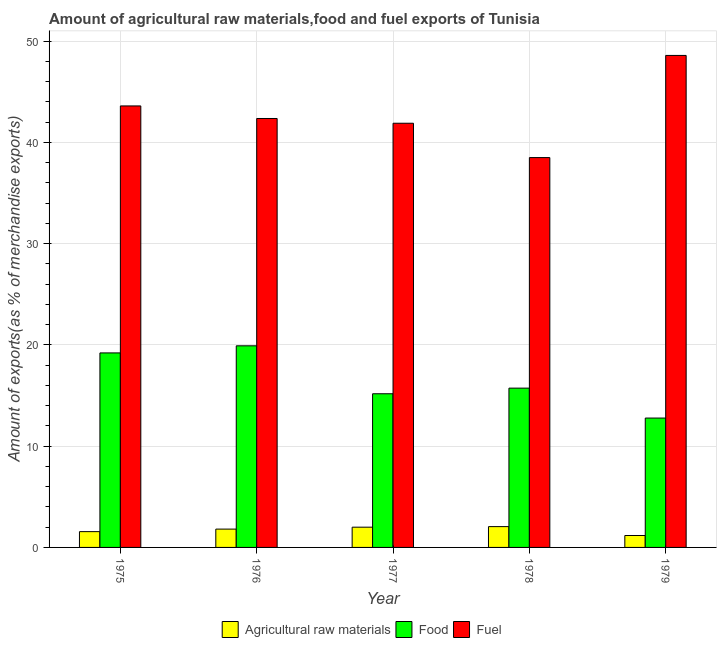How many groups of bars are there?
Ensure brevity in your answer.  5. How many bars are there on the 3rd tick from the left?
Ensure brevity in your answer.  3. How many bars are there on the 4th tick from the right?
Provide a short and direct response. 3. What is the label of the 4th group of bars from the left?
Your response must be concise. 1978. What is the percentage of food exports in 1976?
Ensure brevity in your answer.  19.91. Across all years, what is the maximum percentage of food exports?
Keep it short and to the point. 19.91. Across all years, what is the minimum percentage of raw materials exports?
Offer a terse response. 1.18. In which year was the percentage of food exports maximum?
Provide a succinct answer. 1976. In which year was the percentage of raw materials exports minimum?
Your answer should be very brief. 1979. What is the total percentage of raw materials exports in the graph?
Provide a succinct answer. 8.6. What is the difference between the percentage of food exports in 1975 and that in 1978?
Give a very brief answer. 3.48. What is the difference between the percentage of fuel exports in 1975 and the percentage of food exports in 1979?
Provide a succinct answer. -4.99. What is the average percentage of food exports per year?
Your answer should be very brief. 16.56. In the year 1975, what is the difference between the percentage of fuel exports and percentage of food exports?
Make the answer very short. 0. What is the ratio of the percentage of raw materials exports in 1975 to that in 1977?
Keep it short and to the point. 0.78. Is the percentage of food exports in 1978 less than that in 1979?
Ensure brevity in your answer.  No. Is the difference between the percentage of fuel exports in 1975 and 1978 greater than the difference between the percentage of raw materials exports in 1975 and 1978?
Provide a succinct answer. No. What is the difference between the highest and the second highest percentage of raw materials exports?
Offer a very short reply. 0.06. What is the difference between the highest and the lowest percentage of raw materials exports?
Make the answer very short. 0.88. Is the sum of the percentage of fuel exports in 1975 and 1979 greater than the maximum percentage of raw materials exports across all years?
Your answer should be very brief. Yes. What does the 2nd bar from the left in 1976 represents?
Ensure brevity in your answer.  Food. What does the 3rd bar from the right in 1976 represents?
Ensure brevity in your answer.  Agricultural raw materials. How many bars are there?
Make the answer very short. 15. Are all the bars in the graph horizontal?
Your answer should be very brief. No. How many years are there in the graph?
Your response must be concise. 5. What is the difference between two consecutive major ticks on the Y-axis?
Your answer should be very brief. 10. Are the values on the major ticks of Y-axis written in scientific E-notation?
Your response must be concise. No. How are the legend labels stacked?
Ensure brevity in your answer.  Horizontal. What is the title of the graph?
Offer a very short reply. Amount of agricultural raw materials,food and fuel exports of Tunisia. Does "Secondary education" appear as one of the legend labels in the graph?
Ensure brevity in your answer.  No. What is the label or title of the Y-axis?
Give a very brief answer. Amount of exports(as % of merchandise exports). What is the Amount of exports(as % of merchandise exports) in Agricultural raw materials in 1975?
Ensure brevity in your answer.  1.56. What is the Amount of exports(as % of merchandise exports) of Food in 1975?
Offer a very short reply. 19.21. What is the Amount of exports(as % of merchandise exports) of Fuel in 1975?
Give a very brief answer. 43.6. What is the Amount of exports(as % of merchandise exports) in Agricultural raw materials in 1976?
Make the answer very short. 1.81. What is the Amount of exports(as % of merchandise exports) of Food in 1976?
Keep it short and to the point. 19.91. What is the Amount of exports(as % of merchandise exports) of Fuel in 1976?
Your answer should be compact. 42.36. What is the Amount of exports(as % of merchandise exports) in Agricultural raw materials in 1977?
Provide a succinct answer. 2. What is the Amount of exports(as % of merchandise exports) in Food in 1977?
Provide a short and direct response. 15.17. What is the Amount of exports(as % of merchandise exports) of Fuel in 1977?
Keep it short and to the point. 41.89. What is the Amount of exports(as % of merchandise exports) of Agricultural raw materials in 1978?
Ensure brevity in your answer.  2.06. What is the Amount of exports(as % of merchandise exports) in Food in 1978?
Offer a terse response. 15.73. What is the Amount of exports(as % of merchandise exports) in Fuel in 1978?
Your answer should be very brief. 38.49. What is the Amount of exports(as % of merchandise exports) in Agricultural raw materials in 1979?
Offer a terse response. 1.18. What is the Amount of exports(as % of merchandise exports) of Food in 1979?
Offer a terse response. 12.77. What is the Amount of exports(as % of merchandise exports) of Fuel in 1979?
Your answer should be very brief. 48.58. Across all years, what is the maximum Amount of exports(as % of merchandise exports) in Agricultural raw materials?
Your response must be concise. 2.06. Across all years, what is the maximum Amount of exports(as % of merchandise exports) in Food?
Make the answer very short. 19.91. Across all years, what is the maximum Amount of exports(as % of merchandise exports) in Fuel?
Your answer should be very brief. 48.58. Across all years, what is the minimum Amount of exports(as % of merchandise exports) of Agricultural raw materials?
Give a very brief answer. 1.18. Across all years, what is the minimum Amount of exports(as % of merchandise exports) of Food?
Provide a succinct answer. 12.77. Across all years, what is the minimum Amount of exports(as % of merchandise exports) in Fuel?
Offer a very short reply. 38.49. What is the total Amount of exports(as % of merchandise exports) in Agricultural raw materials in the graph?
Offer a very short reply. 8.6. What is the total Amount of exports(as % of merchandise exports) in Food in the graph?
Give a very brief answer. 82.79. What is the total Amount of exports(as % of merchandise exports) in Fuel in the graph?
Offer a very short reply. 214.91. What is the difference between the Amount of exports(as % of merchandise exports) in Agricultural raw materials in 1975 and that in 1976?
Make the answer very short. -0.25. What is the difference between the Amount of exports(as % of merchandise exports) in Food in 1975 and that in 1976?
Keep it short and to the point. -0.7. What is the difference between the Amount of exports(as % of merchandise exports) in Fuel in 1975 and that in 1976?
Give a very brief answer. 1.24. What is the difference between the Amount of exports(as % of merchandise exports) in Agricultural raw materials in 1975 and that in 1977?
Provide a succinct answer. -0.44. What is the difference between the Amount of exports(as % of merchandise exports) in Food in 1975 and that in 1977?
Your answer should be very brief. 4.03. What is the difference between the Amount of exports(as % of merchandise exports) in Fuel in 1975 and that in 1977?
Make the answer very short. 1.71. What is the difference between the Amount of exports(as % of merchandise exports) of Agricultural raw materials in 1975 and that in 1978?
Your answer should be very brief. -0.5. What is the difference between the Amount of exports(as % of merchandise exports) of Food in 1975 and that in 1978?
Offer a terse response. 3.48. What is the difference between the Amount of exports(as % of merchandise exports) of Fuel in 1975 and that in 1978?
Offer a very short reply. 5.1. What is the difference between the Amount of exports(as % of merchandise exports) of Agricultural raw materials in 1975 and that in 1979?
Make the answer very short. 0.38. What is the difference between the Amount of exports(as % of merchandise exports) of Food in 1975 and that in 1979?
Your response must be concise. 6.43. What is the difference between the Amount of exports(as % of merchandise exports) in Fuel in 1975 and that in 1979?
Provide a short and direct response. -4.99. What is the difference between the Amount of exports(as % of merchandise exports) in Agricultural raw materials in 1976 and that in 1977?
Give a very brief answer. -0.19. What is the difference between the Amount of exports(as % of merchandise exports) in Food in 1976 and that in 1977?
Keep it short and to the point. 4.73. What is the difference between the Amount of exports(as % of merchandise exports) in Fuel in 1976 and that in 1977?
Make the answer very short. 0.47. What is the difference between the Amount of exports(as % of merchandise exports) of Agricultural raw materials in 1976 and that in 1978?
Provide a succinct answer. -0.25. What is the difference between the Amount of exports(as % of merchandise exports) of Food in 1976 and that in 1978?
Give a very brief answer. 4.18. What is the difference between the Amount of exports(as % of merchandise exports) of Fuel in 1976 and that in 1978?
Provide a short and direct response. 3.86. What is the difference between the Amount of exports(as % of merchandise exports) of Agricultural raw materials in 1976 and that in 1979?
Offer a terse response. 0.63. What is the difference between the Amount of exports(as % of merchandise exports) in Food in 1976 and that in 1979?
Your answer should be compact. 7.13. What is the difference between the Amount of exports(as % of merchandise exports) in Fuel in 1976 and that in 1979?
Your answer should be compact. -6.23. What is the difference between the Amount of exports(as % of merchandise exports) in Agricultural raw materials in 1977 and that in 1978?
Provide a short and direct response. -0.06. What is the difference between the Amount of exports(as % of merchandise exports) in Food in 1977 and that in 1978?
Offer a very short reply. -0.56. What is the difference between the Amount of exports(as % of merchandise exports) of Fuel in 1977 and that in 1978?
Make the answer very short. 3.39. What is the difference between the Amount of exports(as % of merchandise exports) of Agricultural raw materials in 1977 and that in 1979?
Offer a very short reply. 0.82. What is the difference between the Amount of exports(as % of merchandise exports) of Food in 1977 and that in 1979?
Provide a succinct answer. 2.4. What is the difference between the Amount of exports(as % of merchandise exports) of Fuel in 1977 and that in 1979?
Your answer should be compact. -6.7. What is the difference between the Amount of exports(as % of merchandise exports) in Agricultural raw materials in 1978 and that in 1979?
Offer a very short reply. 0.88. What is the difference between the Amount of exports(as % of merchandise exports) in Food in 1978 and that in 1979?
Your answer should be compact. 2.96. What is the difference between the Amount of exports(as % of merchandise exports) in Fuel in 1978 and that in 1979?
Provide a short and direct response. -10.09. What is the difference between the Amount of exports(as % of merchandise exports) of Agricultural raw materials in 1975 and the Amount of exports(as % of merchandise exports) of Food in 1976?
Provide a short and direct response. -18.35. What is the difference between the Amount of exports(as % of merchandise exports) of Agricultural raw materials in 1975 and the Amount of exports(as % of merchandise exports) of Fuel in 1976?
Your answer should be compact. -40.8. What is the difference between the Amount of exports(as % of merchandise exports) in Food in 1975 and the Amount of exports(as % of merchandise exports) in Fuel in 1976?
Make the answer very short. -23.15. What is the difference between the Amount of exports(as % of merchandise exports) in Agricultural raw materials in 1975 and the Amount of exports(as % of merchandise exports) in Food in 1977?
Your answer should be compact. -13.61. What is the difference between the Amount of exports(as % of merchandise exports) of Agricultural raw materials in 1975 and the Amount of exports(as % of merchandise exports) of Fuel in 1977?
Keep it short and to the point. -40.33. What is the difference between the Amount of exports(as % of merchandise exports) in Food in 1975 and the Amount of exports(as % of merchandise exports) in Fuel in 1977?
Provide a short and direct response. -22.68. What is the difference between the Amount of exports(as % of merchandise exports) in Agricultural raw materials in 1975 and the Amount of exports(as % of merchandise exports) in Food in 1978?
Ensure brevity in your answer.  -14.17. What is the difference between the Amount of exports(as % of merchandise exports) of Agricultural raw materials in 1975 and the Amount of exports(as % of merchandise exports) of Fuel in 1978?
Offer a terse response. -36.94. What is the difference between the Amount of exports(as % of merchandise exports) in Food in 1975 and the Amount of exports(as % of merchandise exports) in Fuel in 1978?
Your answer should be compact. -19.29. What is the difference between the Amount of exports(as % of merchandise exports) of Agricultural raw materials in 1975 and the Amount of exports(as % of merchandise exports) of Food in 1979?
Give a very brief answer. -11.21. What is the difference between the Amount of exports(as % of merchandise exports) of Agricultural raw materials in 1975 and the Amount of exports(as % of merchandise exports) of Fuel in 1979?
Your response must be concise. -47.02. What is the difference between the Amount of exports(as % of merchandise exports) of Food in 1975 and the Amount of exports(as % of merchandise exports) of Fuel in 1979?
Ensure brevity in your answer.  -29.38. What is the difference between the Amount of exports(as % of merchandise exports) of Agricultural raw materials in 1976 and the Amount of exports(as % of merchandise exports) of Food in 1977?
Provide a short and direct response. -13.37. What is the difference between the Amount of exports(as % of merchandise exports) of Agricultural raw materials in 1976 and the Amount of exports(as % of merchandise exports) of Fuel in 1977?
Provide a short and direct response. -40.08. What is the difference between the Amount of exports(as % of merchandise exports) of Food in 1976 and the Amount of exports(as % of merchandise exports) of Fuel in 1977?
Give a very brief answer. -21.98. What is the difference between the Amount of exports(as % of merchandise exports) of Agricultural raw materials in 1976 and the Amount of exports(as % of merchandise exports) of Food in 1978?
Provide a succinct answer. -13.92. What is the difference between the Amount of exports(as % of merchandise exports) of Agricultural raw materials in 1976 and the Amount of exports(as % of merchandise exports) of Fuel in 1978?
Provide a short and direct response. -36.69. What is the difference between the Amount of exports(as % of merchandise exports) in Food in 1976 and the Amount of exports(as % of merchandise exports) in Fuel in 1978?
Ensure brevity in your answer.  -18.59. What is the difference between the Amount of exports(as % of merchandise exports) of Agricultural raw materials in 1976 and the Amount of exports(as % of merchandise exports) of Food in 1979?
Keep it short and to the point. -10.97. What is the difference between the Amount of exports(as % of merchandise exports) in Agricultural raw materials in 1976 and the Amount of exports(as % of merchandise exports) in Fuel in 1979?
Offer a terse response. -46.77. What is the difference between the Amount of exports(as % of merchandise exports) of Food in 1976 and the Amount of exports(as % of merchandise exports) of Fuel in 1979?
Make the answer very short. -28.67. What is the difference between the Amount of exports(as % of merchandise exports) of Agricultural raw materials in 1977 and the Amount of exports(as % of merchandise exports) of Food in 1978?
Give a very brief answer. -13.73. What is the difference between the Amount of exports(as % of merchandise exports) of Agricultural raw materials in 1977 and the Amount of exports(as % of merchandise exports) of Fuel in 1978?
Your answer should be compact. -36.5. What is the difference between the Amount of exports(as % of merchandise exports) of Food in 1977 and the Amount of exports(as % of merchandise exports) of Fuel in 1978?
Your response must be concise. -23.32. What is the difference between the Amount of exports(as % of merchandise exports) in Agricultural raw materials in 1977 and the Amount of exports(as % of merchandise exports) in Food in 1979?
Keep it short and to the point. -10.78. What is the difference between the Amount of exports(as % of merchandise exports) in Agricultural raw materials in 1977 and the Amount of exports(as % of merchandise exports) in Fuel in 1979?
Offer a terse response. -46.58. What is the difference between the Amount of exports(as % of merchandise exports) in Food in 1977 and the Amount of exports(as % of merchandise exports) in Fuel in 1979?
Make the answer very short. -33.41. What is the difference between the Amount of exports(as % of merchandise exports) in Agricultural raw materials in 1978 and the Amount of exports(as % of merchandise exports) in Food in 1979?
Make the answer very short. -10.72. What is the difference between the Amount of exports(as % of merchandise exports) of Agricultural raw materials in 1978 and the Amount of exports(as % of merchandise exports) of Fuel in 1979?
Offer a terse response. -46.53. What is the difference between the Amount of exports(as % of merchandise exports) of Food in 1978 and the Amount of exports(as % of merchandise exports) of Fuel in 1979?
Your response must be concise. -32.85. What is the average Amount of exports(as % of merchandise exports) in Agricultural raw materials per year?
Provide a succinct answer. 1.72. What is the average Amount of exports(as % of merchandise exports) of Food per year?
Offer a very short reply. 16.56. What is the average Amount of exports(as % of merchandise exports) in Fuel per year?
Your response must be concise. 42.98. In the year 1975, what is the difference between the Amount of exports(as % of merchandise exports) of Agricultural raw materials and Amount of exports(as % of merchandise exports) of Food?
Ensure brevity in your answer.  -17.65. In the year 1975, what is the difference between the Amount of exports(as % of merchandise exports) in Agricultural raw materials and Amount of exports(as % of merchandise exports) in Fuel?
Ensure brevity in your answer.  -42.04. In the year 1975, what is the difference between the Amount of exports(as % of merchandise exports) in Food and Amount of exports(as % of merchandise exports) in Fuel?
Your answer should be very brief. -24.39. In the year 1976, what is the difference between the Amount of exports(as % of merchandise exports) of Agricultural raw materials and Amount of exports(as % of merchandise exports) of Food?
Provide a succinct answer. -18.1. In the year 1976, what is the difference between the Amount of exports(as % of merchandise exports) in Agricultural raw materials and Amount of exports(as % of merchandise exports) in Fuel?
Provide a succinct answer. -40.55. In the year 1976, what is the difference between the Amount of exports(as % of merchandise exports) of Food and Amount of exports(as % of merchandise exports) of Fuel?
Ensure brevity in your answer.  -22.45. In the year 1977, what is the difference between the Amount of exports(as % of merchandise exports) of Agricultural raw materials and Amount of exports(as % of merchandise exports) of Food?
Keep it short and to the point. -13.18. In the year 1977, what is the difference between the Amount of exports(as % of merchandise exports) of Agricultural raw materials and Amount of exports(as % of merchandise exports) of Fuel?
Offer a very short reply. -39.89. In the year 1977, what is the difference between the Amount of exports(as % of merchandise exports) in Food and Amount of exports(as % of merchandise exports) in Fuel?
Provide a short and direct response. -26.71. In the year 1978, what is the difference between the Amount of exports(as % of merchandise exports) in Agricultural raw materials and Amount of exports(as % of merchandise exports) in Food?
Ensure brevity in your answer.  -13.67. In the year 1978, what is the difference between the Amount of exports(as % of merchandise exports) in Agricultural raw materials and Amount of exports(as % of merchandise exports) in Fuel?
Make the answer very short. -36.44. In the year 1978, what is the difference between the Amount of exports(as % of merchandise exports) in Food and Amount of exports(as % of merchandise exports) in Fuel?
Your response must be concise. -22.76. In the year 1979, what is the difference between the Amount of exports(as % of merchandise exports) in Agricultural raw materials and Amount of exports(as % of merchandise exports) in Food?
Your response must be concise. -11.6. In the year 1979, what is the difference between the Amount of exports(as % of merchandise exports) in Agricultural raw materials and Amount of exports(as % of merchandise exports) in Fuel?
Give a very brief answer. -47.41. In the year 1979, what is the difference between the Amount of exports(as % of merchandise exports) in Food and Amount of exports(as % of merchandise exports) in Fuel?
Your answer should be very brief. -35.81. What is the ratio of the Amount of exports(as % of merchandise exports) in Agricultural raw materials in 1975 to that in 1976?
Your answer should be compact. 0.86. What is the ratio of the Amount of exports(as % of merchandise exports) of Food in 1975 to that in 1976?
Make the answer very short. 0.96. What is the ratio of the Amount of exports(as % of merchandise exports) in Fuel in 1975 to that in 1976?
Your answer should be very brief. 1.03. What is the ratio of the Amount of exports(as % of merchandise exports) in Agricultural raw materials in 1975 to that in 1977?
Your answer should be very brief. 0.78. What is the ratio of the Amount of exports(as % of merchandise exports) of Food in 1975 to that in 1977?
Your response must be concise. 1.27. What is the ratio of the Amount of exports(as % of merchandise exports) of Fuel in 1975 to that in 1977?
Provide a succinct answer. 1.04. What is the ratio of the Amount of exports(as % of merchandise exports) in Agricultural raw materials in 1975 to that in 1978?
Your response must be concise. 0.76. What is the ratio of the Amount of exports(as % of merchandise exports) in Food in 1975 to that in 1978?
Give a very brief answer. 1.22. What is the ratio of the Amount of exports(as % of merchandise exports) in Fuel in 1975 to that in 1978?
Provide a short and direct response. 1.13. What is the ratio of the Amount of exports(as % of merchandise exports) in Agricultural raw materials in 1975 to that in 1979?
Offer a very short reply. 1.32. What is the ratio of the Amount of exports(as % of merchandise exports) in Food in 1975 to that in 1979?
Provide a short and direct response. 1.5. What is the ratio of the Amount of exports(as % of merchandise exports) of Fuel in 1975 to that in 1979?
Your answer should be very brief. 0.9. What is the ratio of the Amount of exports(as % of merchandise exports) in Agricultural raw materials in 1976 to that in 1977?
Ensure brevity in your answer.  0.9. What is the ratio of the Amount of exports(as % of merchandise exports) of Food in 1976 to that in 1977?
Your response must be concise. 1.31. What is the ratio of the Amount of exports(as % of merchandise exports) of Fuel in 1976 to that in 1977?
Give a very brief answer. 1.01. What is the ratio of the Amount of exports(as % of merchandise exports) in Agricultural raw materials in 1976 to that in 1978?
Provide a succinct answer. 0.88. What is the ratio of the Amount of exports(as % of merchandise exports) of Food in 1976 to that in 1978?
Ensure brevity in your answer.  1.27. What is the ratio of the Amount of exports(as % of merchandise exports) in Fuel in 1976 to that in 1978?
Provide a succinct answer. 1.1. What is the ratio of the Amount of exports(as % of merchandise exports) in Agricultural raw materials in 1976 to that in 1979?
Give a very brief answer. 1.54. What is the ratio of the Amount of exports(as % of merchandise exports) in Food in 1976 to that in 1979?
Your answer should be compact. 1.56. What is the ratio of the Amount of exports(as % of merchandise exports) of Fuel in 1976 to that in 1979?
Your answer should be very brief. 0.87. What is the ratio of the Amount of exports(as % of merchandise exports) in Agricultural raw materials in 1977 to that in 1978?
Make the answer very short. 0.97. What is the ratio of the Amount of exports(as % of merchandise exports) in Food in 1977 to that in 1978?
Keep it short and to the point. 0.96. What is the ratio of the Amount of exports(as % of merchandise exports) of Fuel in 1977 to that in 1978?
Your answer should be very brief. 1.09. What is the ratio of the Amount of exports(as % of merchandise exports) in Agricultural raw materials in 1977 to that in 1979?
Your answer should be very brief. 1.7. What is the ratio of the Amount of exports(as % of merchandise exports) in Food in 1977 to that in 1979?
Offer a terse response. 1.19. What is the ratio of the Amount of exports(as % of merchandise exports) in Fuel in 1977 to that in 1979?
Give a very brief answer. 0.86. What is the ratio of the Amount of exports(as % of merchandise exports) in Agricultural raw materials in 1978 to that in 1979?
Offer a very short reply. 1.75. What is the ratio of the Amount of exports(as % of merchandise exports) in Food in 1978 to that in 1979?
Make the answer very short. 1.23. What is the ratio of the Amount of exports(as % of merchandise exports) of Fuel in 1978 to that in 1979?
Your answer should be compact. 0.79. What is the difference between the highest and the second highest Amount of exports(as % of merchandise exports) in Agricultural raw materials?
Make the answer very short. 0.06. What is the difference between the highest and the second highest Amount of exports(as % of merchandise exports) in Food?
Keep it short and to the point. 0.7. What is the difference between the highest and the second highest Amount of exports(as % of merchandise exports) of Fuel?
Provide a succinct answer. 4.99. What is the difference between the highest and the lowest Amount of exports(as % of merchandise exports) of Agricultural raw materials?
Provide a short and direct response. 0.88. What is the difference between the highest and the lowest Amount of exports(as % of merchandise exports) in Food?
Provide a succinct answer. 7.13. What is the difference between the highest and the lowest Amount of exports(as % of merchandise exports) in Fuel?
Ensure brevity in your answer.  10.09. 